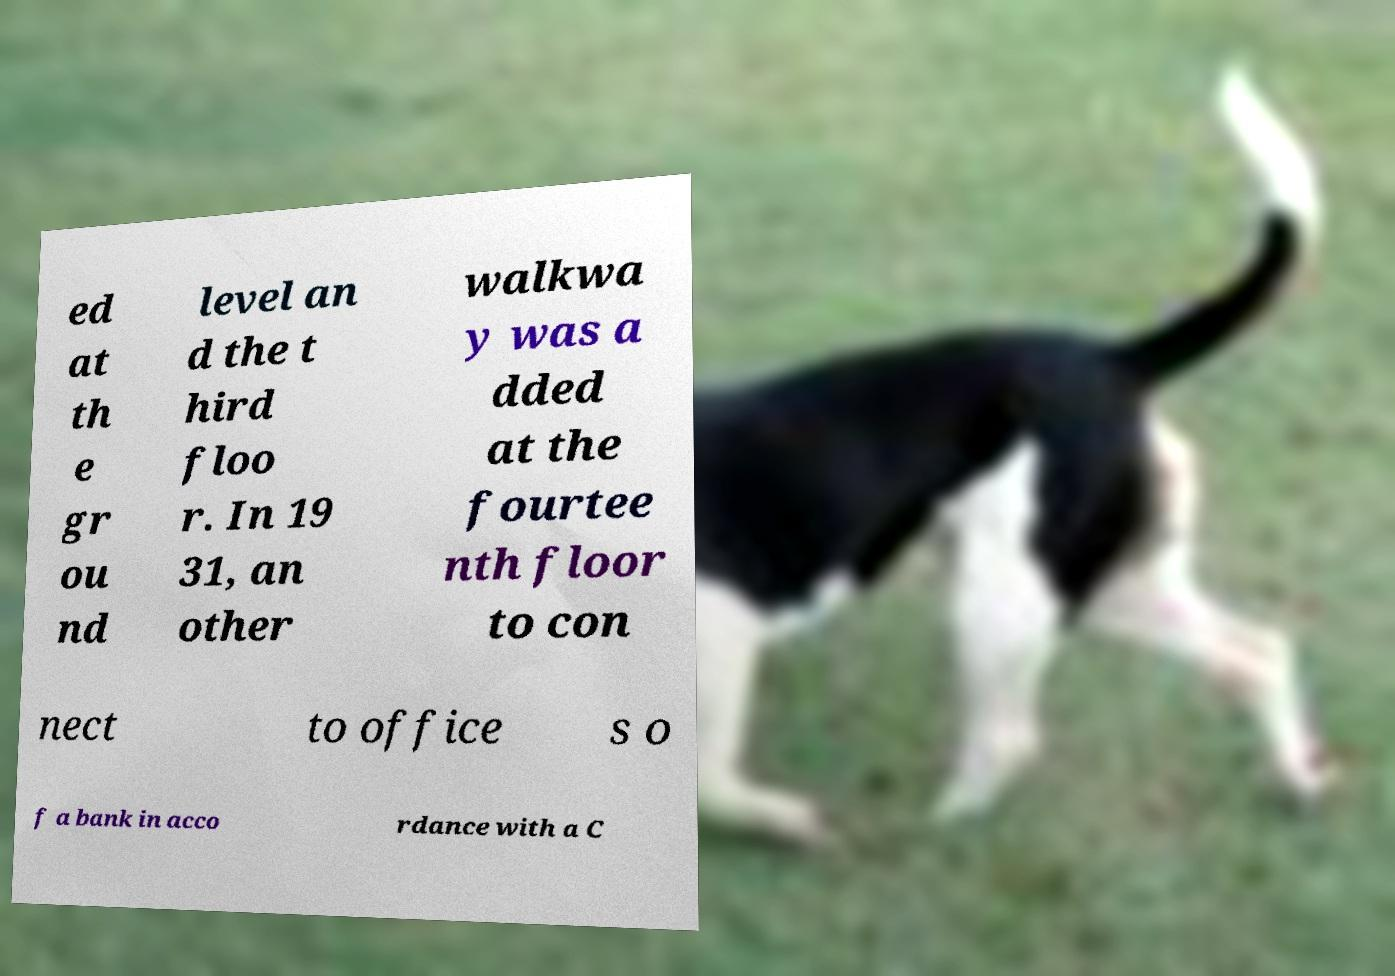For documentation purposes, I need the text within this image transcribed. Could you provide that? ed at th e gr ou nd level an d the t hird floo r. In 19 31, an other walkwa y was a dded at the fourtee nth floor to con nect to office s o f a bank in acco rdance with a C 